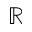Convert formula to latex. <formula><loc_0><loc_0><loc_500><loc_500>\mathbb { R }</formula> 